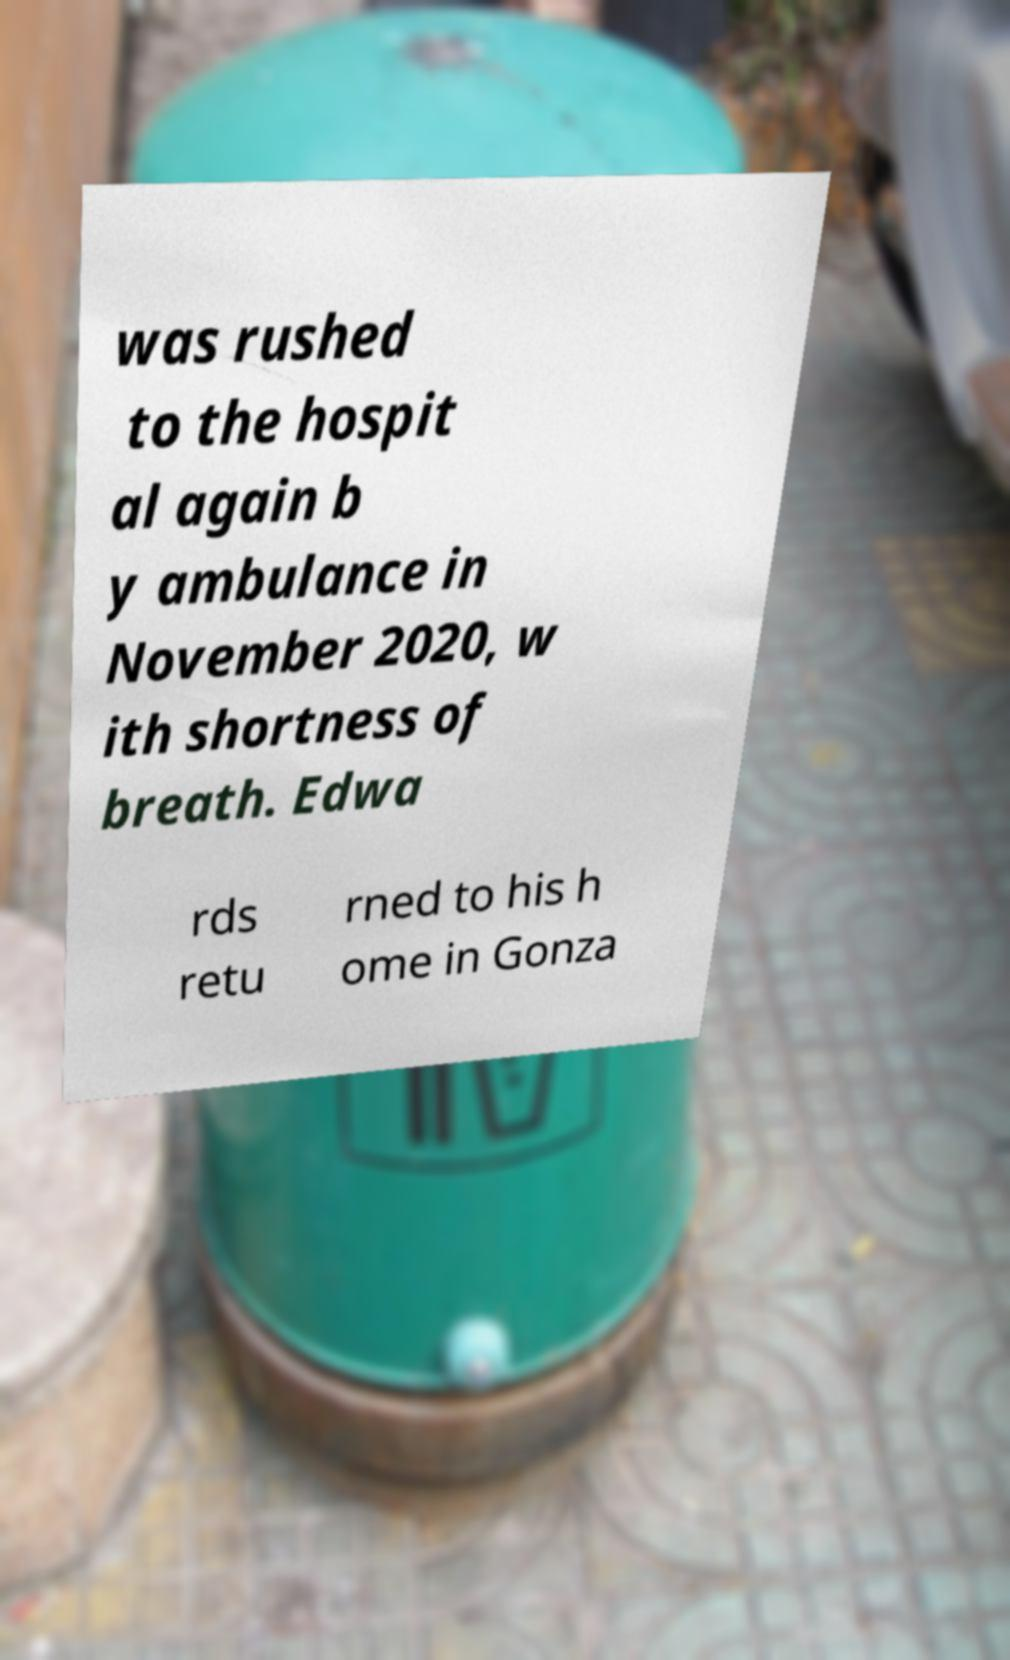I need the written content from this picture converted into text. Can you do that? was rushed to the hospit al again b y ambulance in November 2020, w ith shortness of breath. Edwa rds retu rned to his h ome in Gonza 